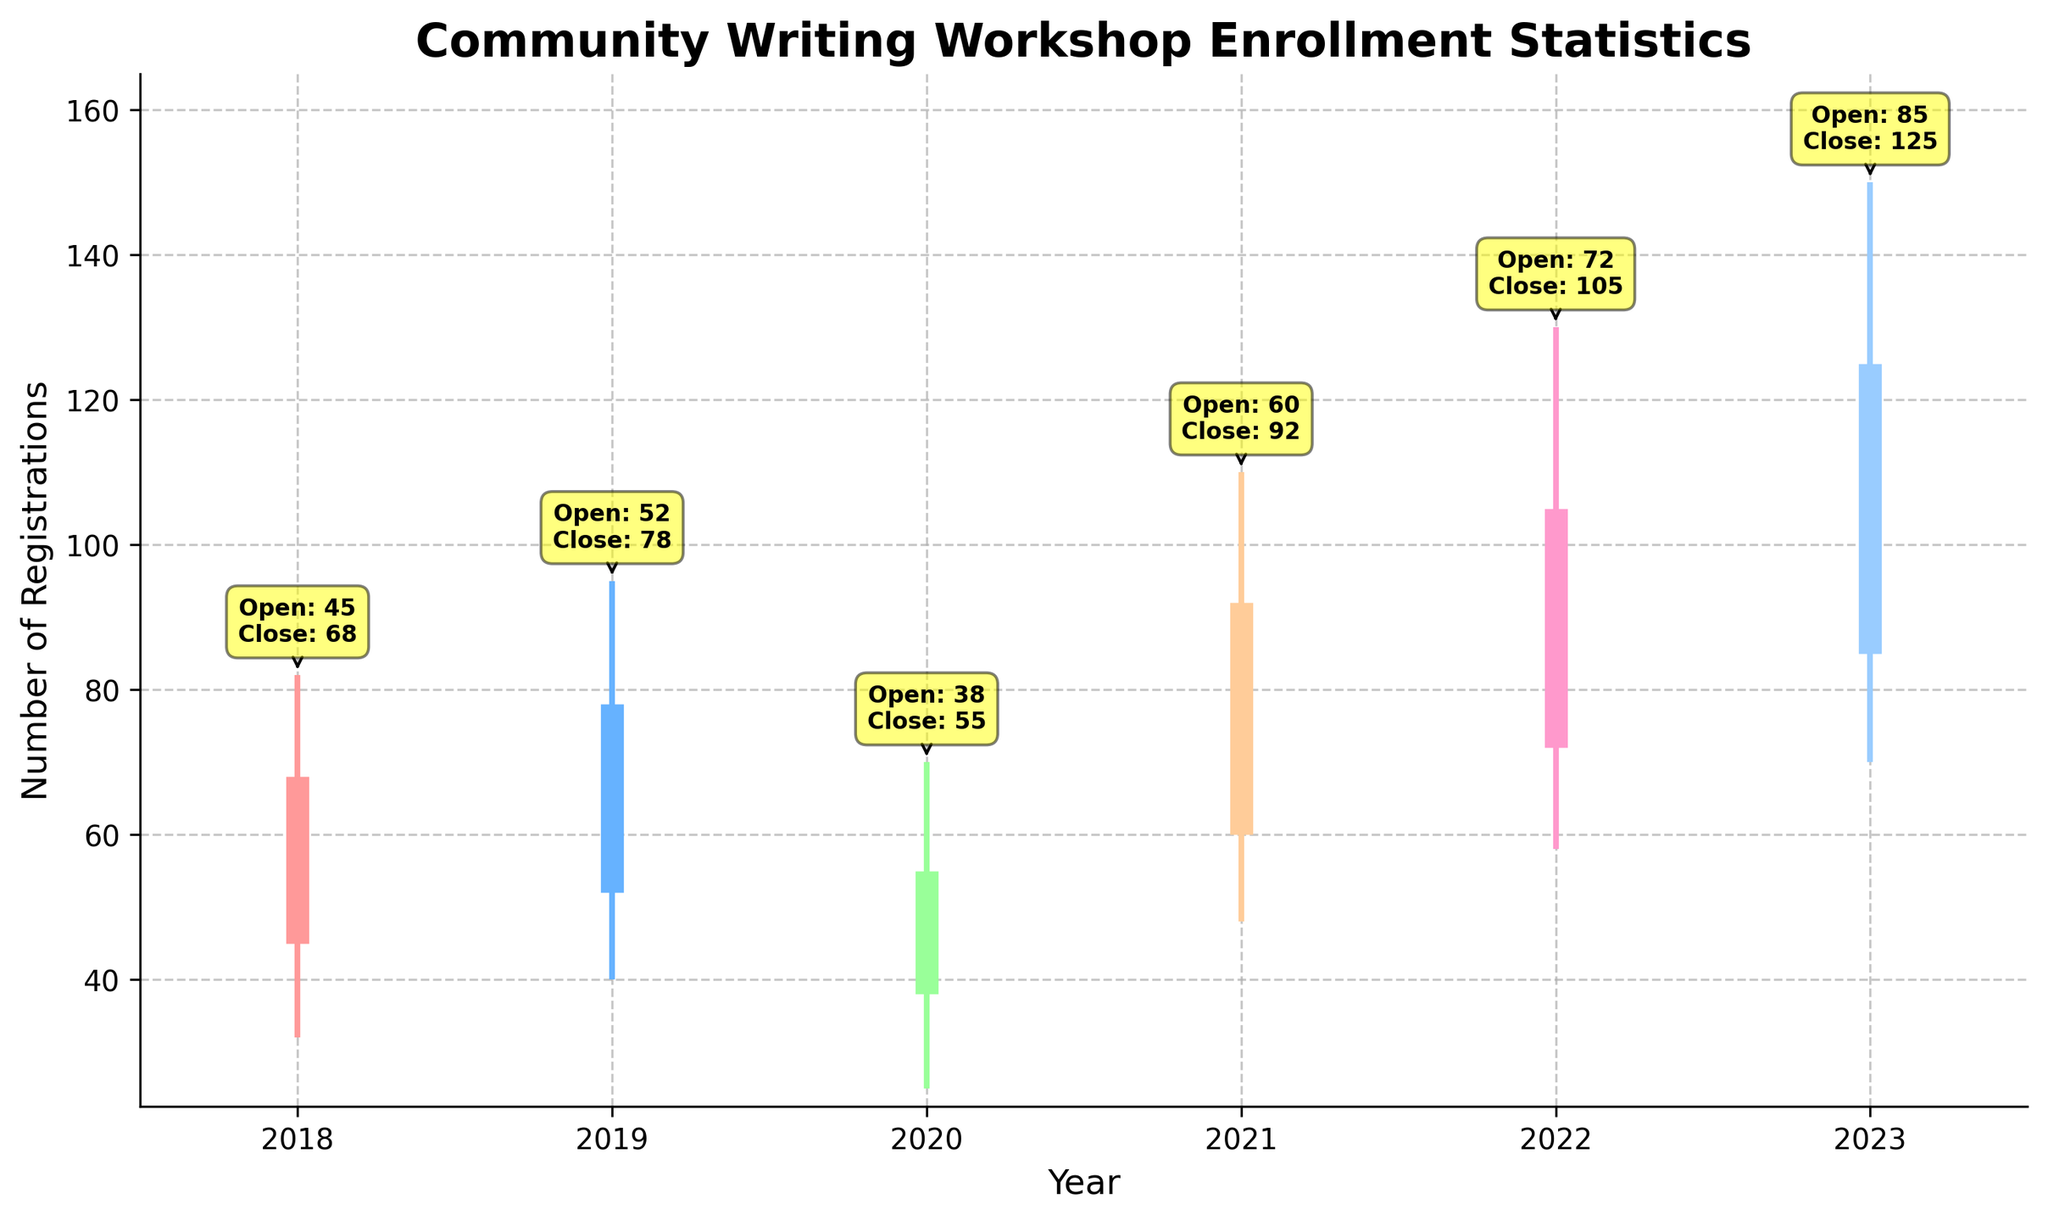How many years of enrollment statistics are displayed? There are data points for each year labeled on the x-axis from 2018 to 2023. Counting the number of years, we get 6.
Answer: 6 What does the title of the figure indicate? The title of the figure indicates that the chart shows enrollment statistics for a community writing workshop over multiple years. This is mentioned in "Community Writing Workshop Enrollment Statistics".
Answer: Enrollment statistics for a community writing workshop Which year had the highest maximum registration number? From the plot, the maximum registration number for each year can be observed at the highest point on the y-axis. The highest point is in the year 2023 with a registration number of 150.
Answer: 2023 What were the opening and closing registration numbers in 2019? The chart has annotations indicating the opening and closing registration numbers for each year. By locating the annotations for 2019, we see that the opening number is 52 and the closing number is 78.
Answer: Open: 52, Close: 78 How much did the maximum registration number increase from 2020 to 2023? The maximum registration number in 2020 was 70, and in 2023 it was 150. The increase can be calculated by subtracting the 2020 value from the 2023 value: 150 - 70 = 80.
Answer: 80 Compare the lowest registration numbers in 2018 and 2021. Which one had a higher low, and by how much? The lowest registration number in 2018 is 32 and in 2021 it is 48. The difference can be found by subtracting 32 from 48: 48 - 32 = 16. Thus, 2021 had a higher low by 16.
Answer: 2021 by 16 What's the average closing registration number over the years? To find the average, sum the closing registration numbers for each year and then divide by the number of years. Closing numbers: 68, 78, 55, 92, 105, 125. Sum: 68 + 78 + 55 + 92 + 105 + 125 = 523. Average: 523 / 6 ≈ 87.17
Answer: ≈ 87.17 In which year was the opening registration number the lowest, and what was the value? By inspecting the opening registration values for each year, the lowest is found in 2020, with a value of 38.
Answer: 2020, 38 How did the opening registration number change from 2018 to 2019? The opening registration number in 2018 was 45 and in 2019 it was 52. The change can be calculated by subtracting the 2018 value from the 2019 value: 52 - 45 = 7.
Answer: Increased by 7 